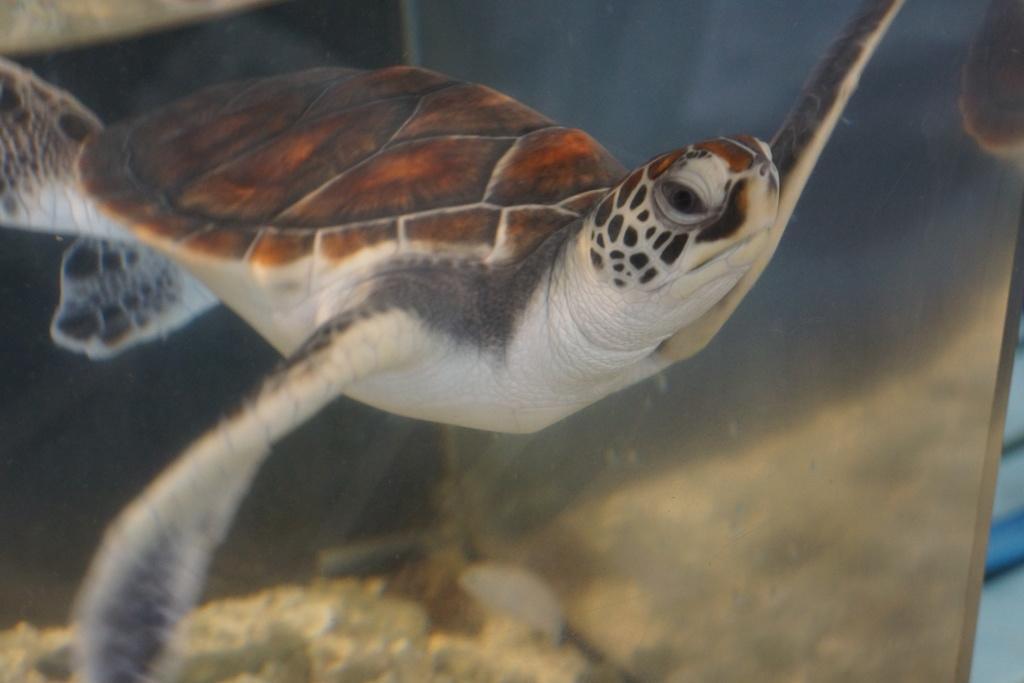Describe this image in one or two sentences. There is a tortoise which is in water. 